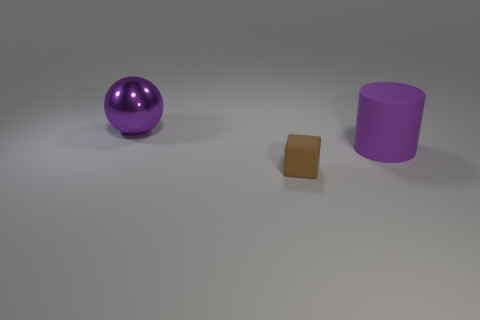Add 1 brown objects. How many objects exist? 4 Subtract all cylinders. How many objects are left? 2 Add 1 spheres. How many spheres are left? 2 Add 1 small purple matte cylinders. How many small purple matte cylinders exist? 1 Subtract 1 purple cylinders. How many objects are left? 2 Subtract 1 cylinders. How many cylinders are left? 0 Subtract all yellow blocks. Subtract all purple balls. How many blocks are left? 1 Subtract all cyan cylinders. How many green balls are left? 0 Subtract all big metallic objects. Subtract all large spheres. How many objects are left? 1 